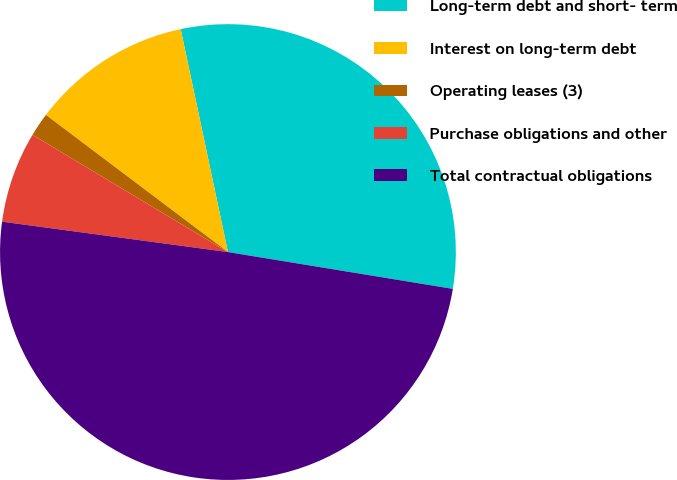Convert chart. <chart><loc_0><loc_0><loc_500><loc_500><pie_chart><fcel>Long-term debt and short- term<fcel>Interest on long-term debt<fcel>Operating leases (3)<fcel>Purchase obligations and other<fcel>Total contractual obligations<nl><fcel>30.91%<fcel>11.4%<fcel>1.68%<fcel>6.47%<fcel>49.55%<nl></chart> 